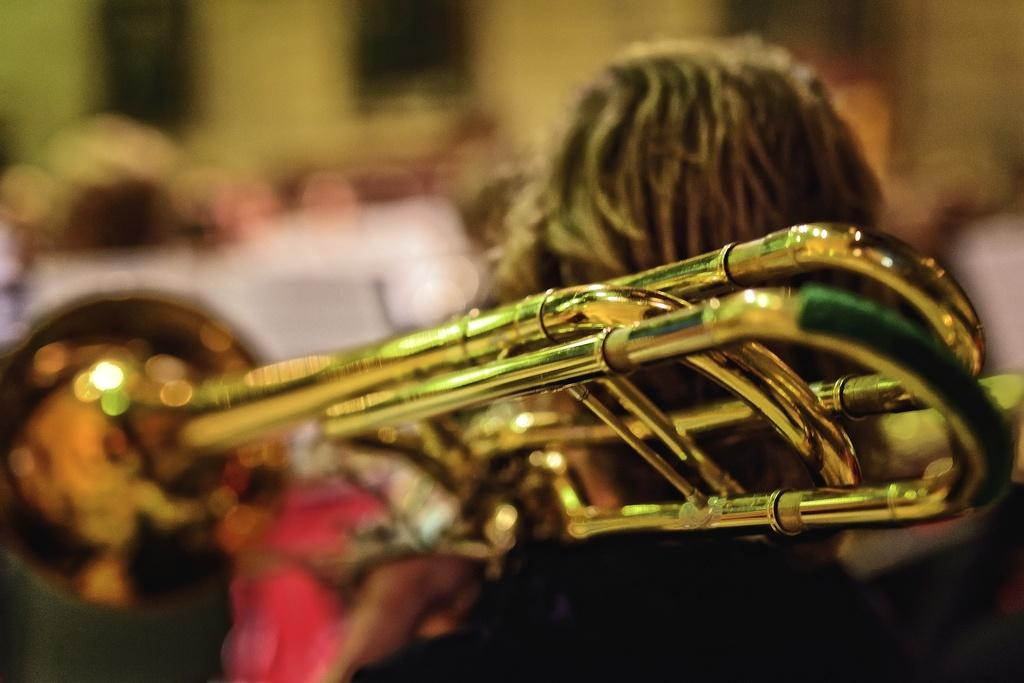What is the person in the image holding? The person in the image is holding a trumpet. Can you describe the people in the background of the image? There is a group of people standing in the background of the image. How many pages are there in the tree in the image? There is no tree or pages present in the image. 